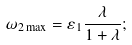<formula> <loc_0><loc_0><loc_500><loc_500>\omega _ { 2 \max } = \varepsilon _ { 1 } \frac { \lambda } { 1 + \lambda } ;</formula> 